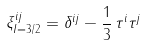<formula> <loc_0><loc_0><loc_500><loc_500>\xi _ { I = 3 / 2 } ^ { i j } = \delta ^ { i j } - \frac { 1 } { 3 } \, \tau ^ { i } \tau ^ { j }</formula> 